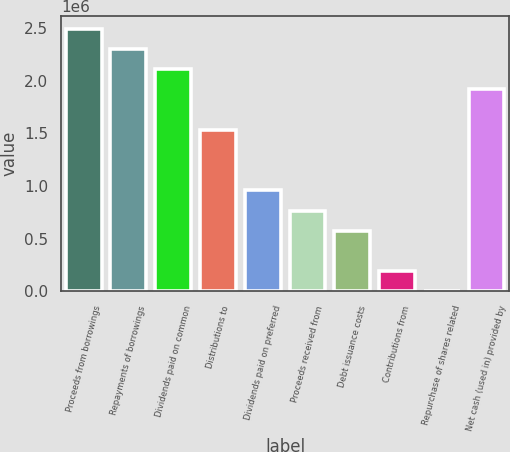Convert chart to OTSL. <chart><loc_0><loc_0><loc_500><loc_500><bar_chart><fcel>Proceeds from borrowings<fcel>Repayments of borrowings<fcel>Dividends paid on common<fcel>Distributions to<fcel>Dividends paid on preferred<fcel>Proceeds received from<fcel>Debt issuance costs<fcel>Contributions from<fcel>Repurchase of shares related<fcel>Net cash (used in) provided by<nl><fcel>2.48913e+06<fcel>2.29769e+06<fcel>2.10625e+06<fcel>1.53193e+06<fcel>957615<fcel>766176<fcel>574736<fcel>191857<fcel>418<fcel>1.91481e+06<nl></chart> 